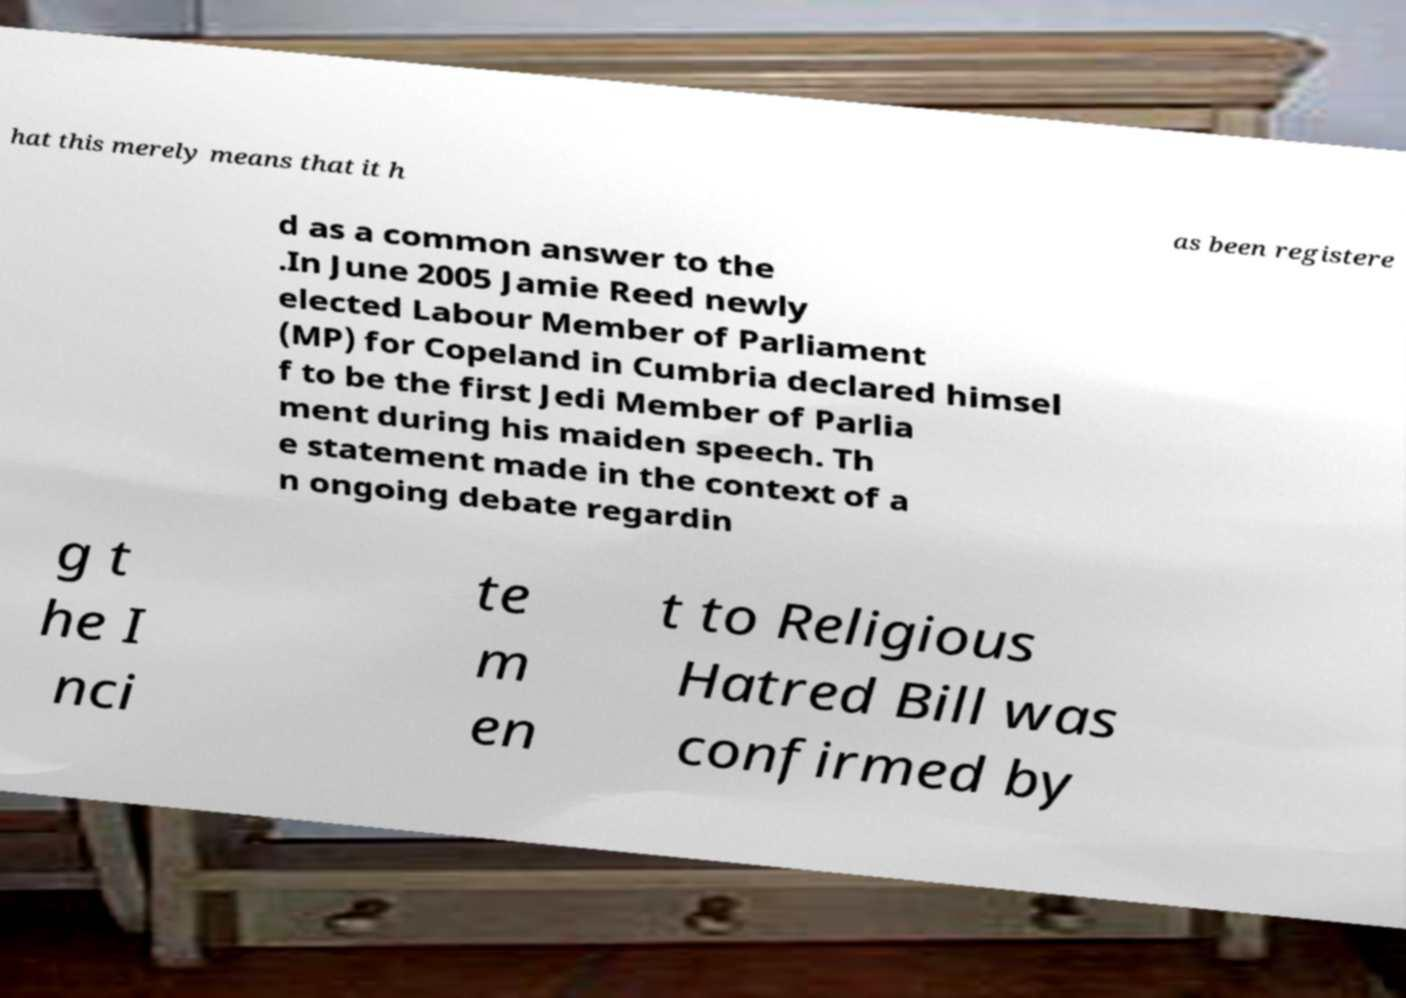I need the written content from this picture converted into text. Can you do that? hat this merely means that it h as been registere d as a common answer to the .In June 2005 Jamie Reed newly elected Labour Member of Parliament (MP) for Copeland in Cumbria declared himsel f to be the first Jedi Member of Parlia ment during his maiden speech. Th e statement made in the context of a n ongoing debate regardin g t he I nci te m en t to Religious Hatred Bill was confirmed by 